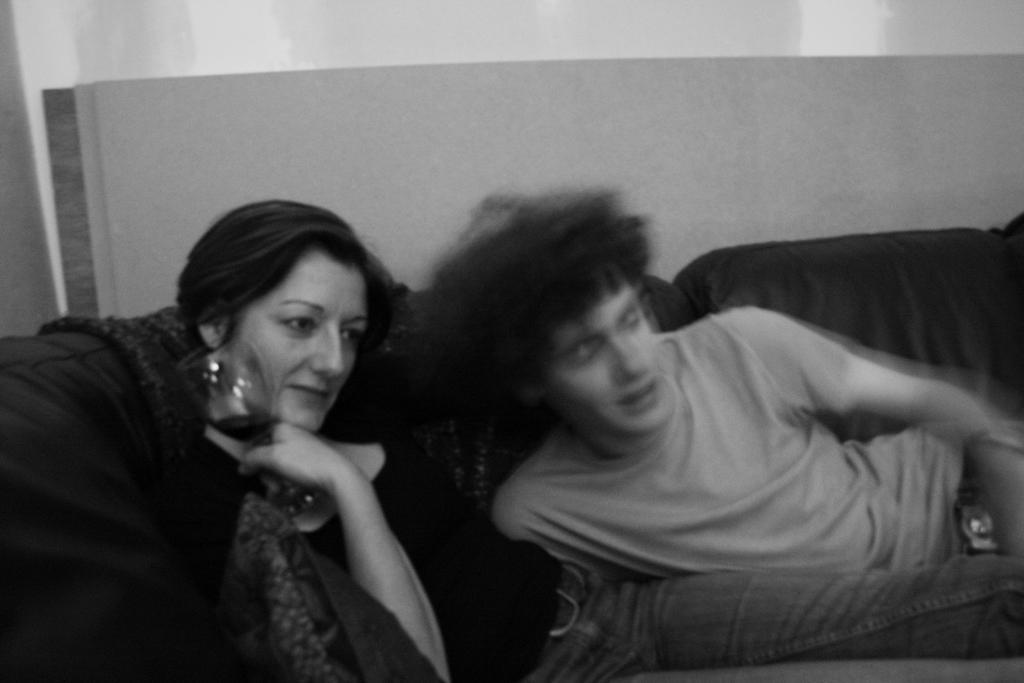Please provide a concise description of this image. In this picture there is man sitting on the sofa and there is a woman sitting and holding the glass. At the back it looks like a wall. 